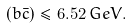Convert formula to latex. <formula><loc_0><loc_0><loc_500><loc_500>( b \bar { c } ) \leq 6 . 5 2 \, G e V .</formula> 